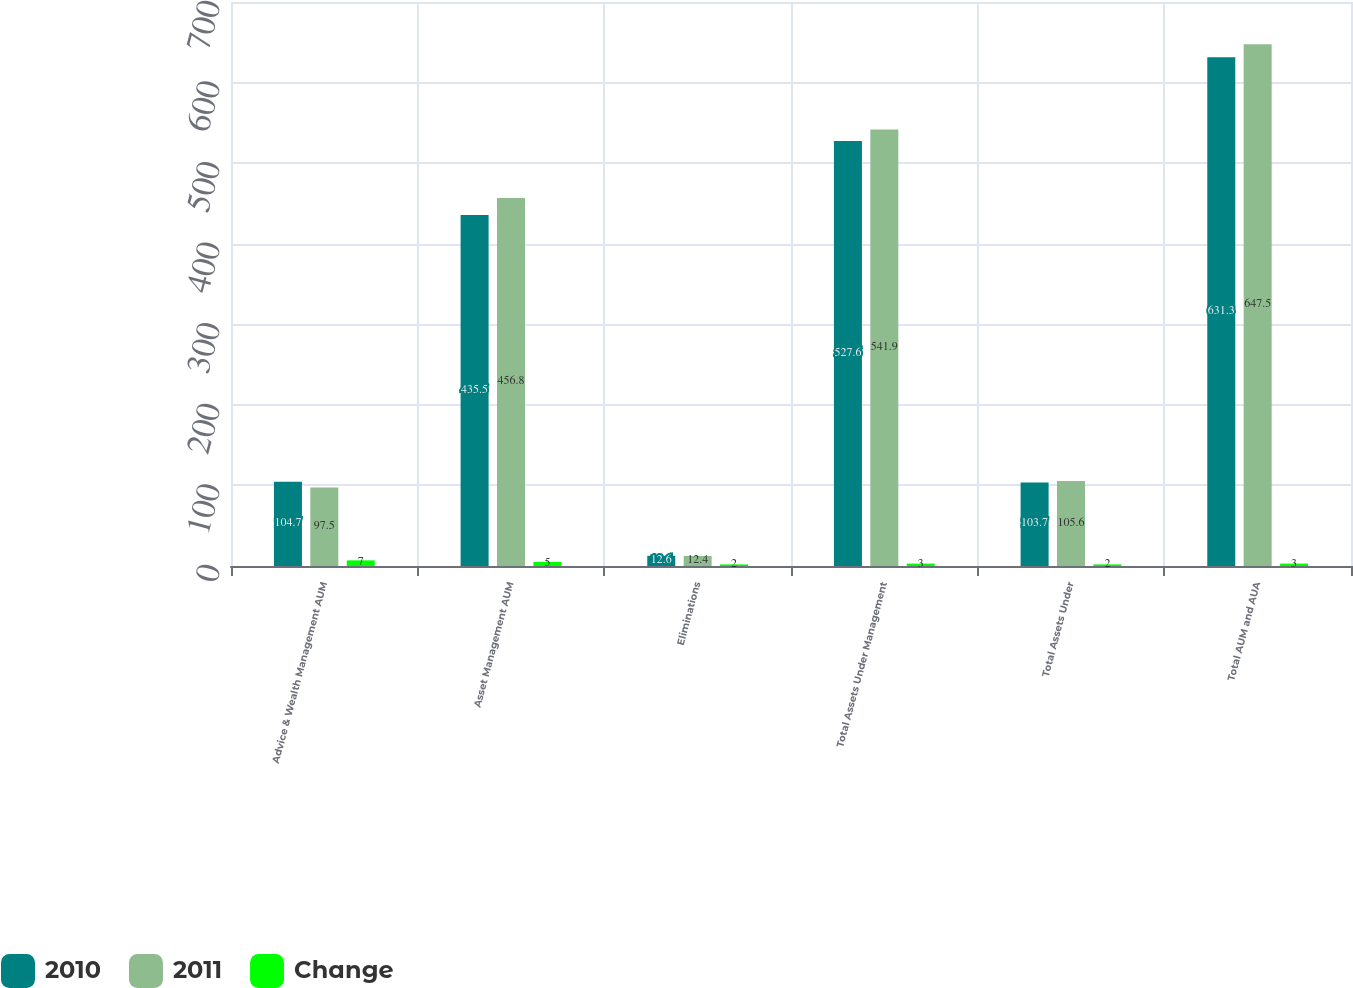<chart> <loc_0><loc_0><loc_500><loc_500><stacked_bar_chart><ecel><fcel>Advice & Wealth Management AUM<fcel>Asset Management AUM<fcel>Eliminations<fcel>Total Assets Under Management<fcel>Total Assets Under<fcel>Total AUM and AUA<nl><fcel>2010<fcel>104.7<fcel>435.5<fcel>12.6<fcel>527.6<fcel>103.7<fcel>631.3<nl><fcel>2011<fcel>97.5<fcel>456.8<fcel>12.4<fcel>541.9<fcel>105.6<fcel>647.5<nl><fcel>Change<fcel>7<fcel>5<fcel>2<fcel>3<fcel>2<fcel>3<nl></chart> 